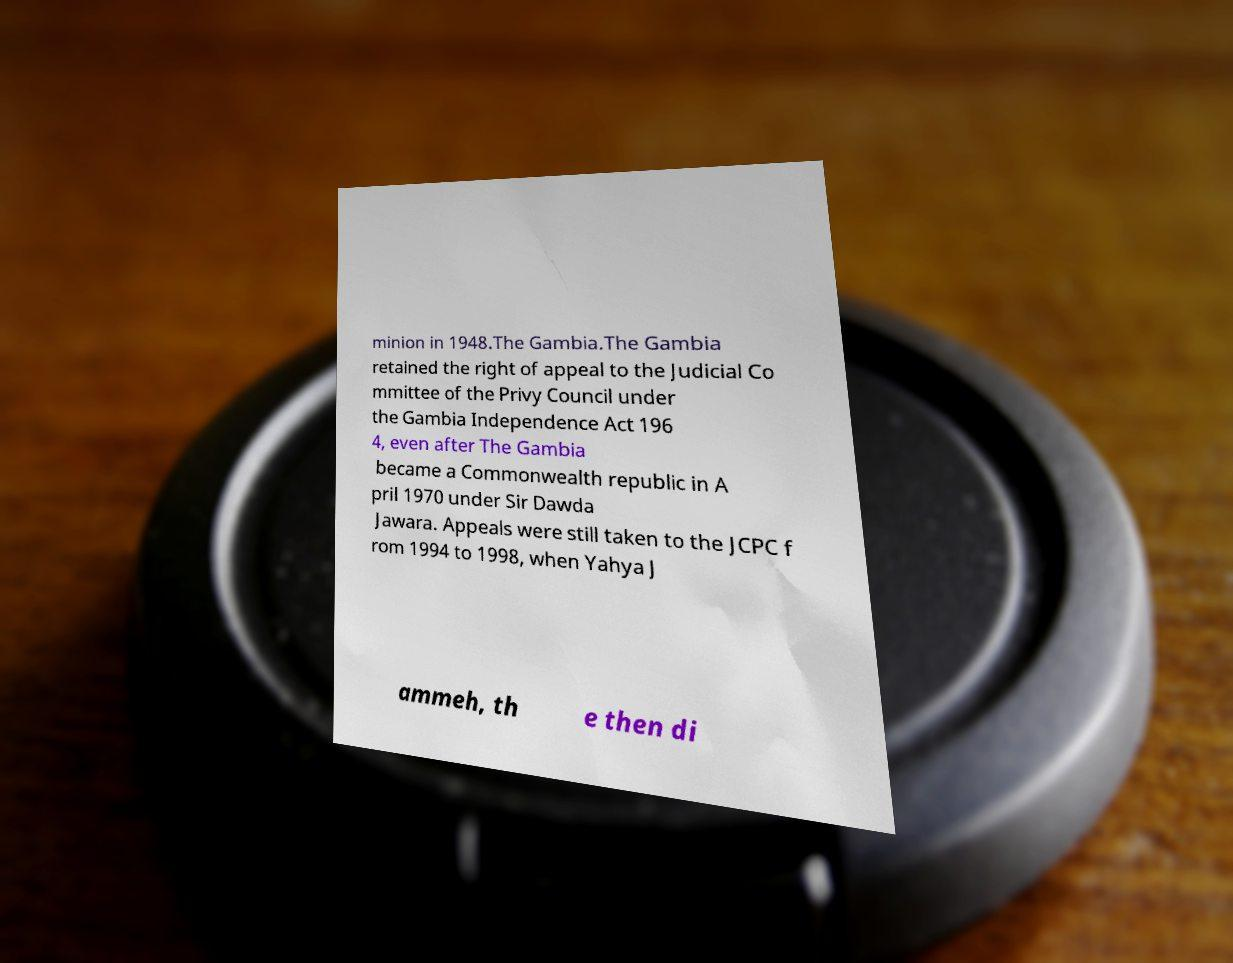Can you accurately transcribe the text from the provided image for me? minion in 1948.The Gambia.The Gambia retained the right of appeal to the Judicial Co mmittee of the Privy Council under the Gambia Independence Act 196 4, even after The Gambia became a Commonwealth republic in A pril 1970 under Sir Dawda Jawara. Appeals were still taken to the JCPC f rom 1994 to 1998, when Yahya J ammeh, th e then di 